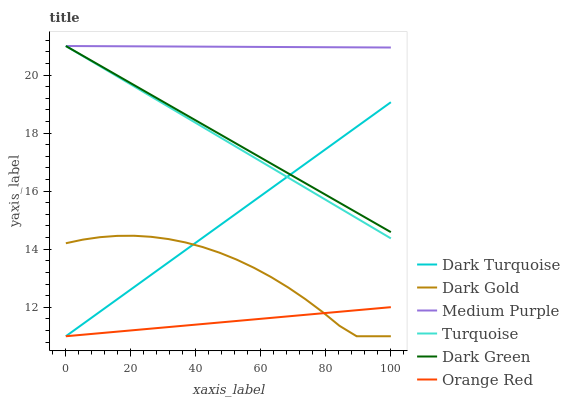Does Dark Gold have the minimum area under the curve?
Answer yes or no. No. Does Dark Gold have the maximum area under the curve?
Answer yes or no. No. Is Dark Turquoise the smoothest?
Answer yes or no. No. Is Dark Turquoise the roughest?
Answer yes or no. No. Does Medium Purple have the lowest value?
Answer yes or no. No. Does Dark Gold have the highest value?
Answer yes or no. No. Is Dark Gold less than Medium Purple?
Answer yes or no. Yes. Is Medium Purple greater than Orange Red?
Answer yes or no. Yes. Does Dark Gold intersect Medium Purple?
Answer yes or no. No. 